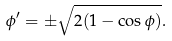Convert formula to latex. <formula><loc_0><loc_0><loc_500><loc_500>\phi ^ { \prime } = \pm \sqrt { 2 ( 1 - \cos \phi ) } .</formula> 